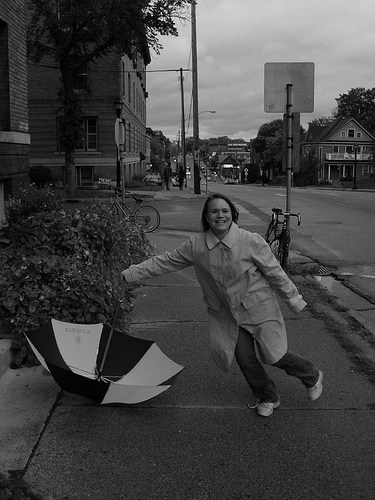<image>What is watering the lawn? It is unknown what is watering the lawn. The various answers suggest it could be rain or a hose. What is watering the lawn? I don't know what is watering the lawn. It can be rain or a hose. 